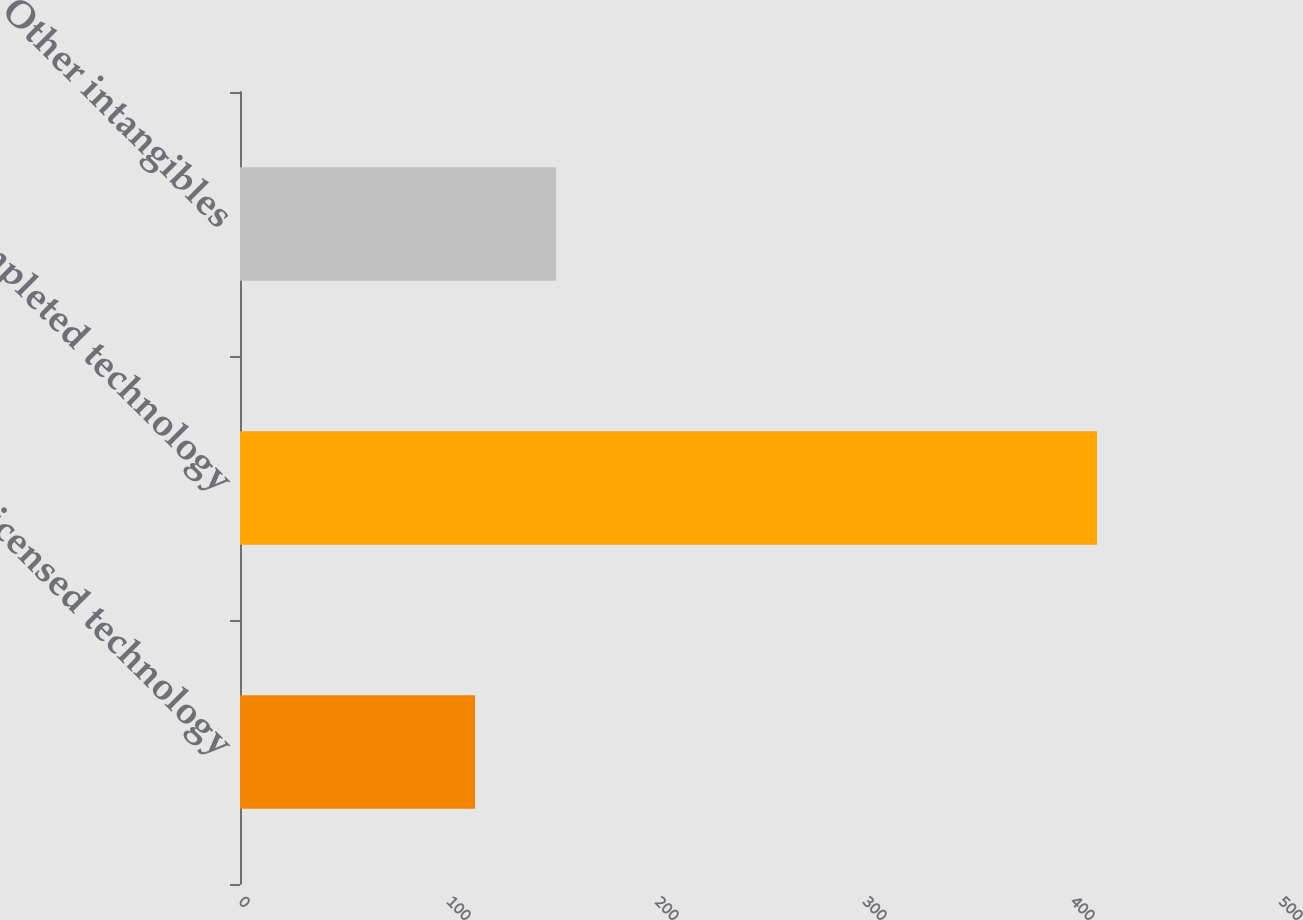Convert chart. <chart><loc_0><loc_0><loc_500><loc_500><bar_chart><fcel>Licensed technology<fcel>Completed technology<fcel>Other intangibles<nl><fcel>113<fcel>412<fcel>152<nl></chart> 